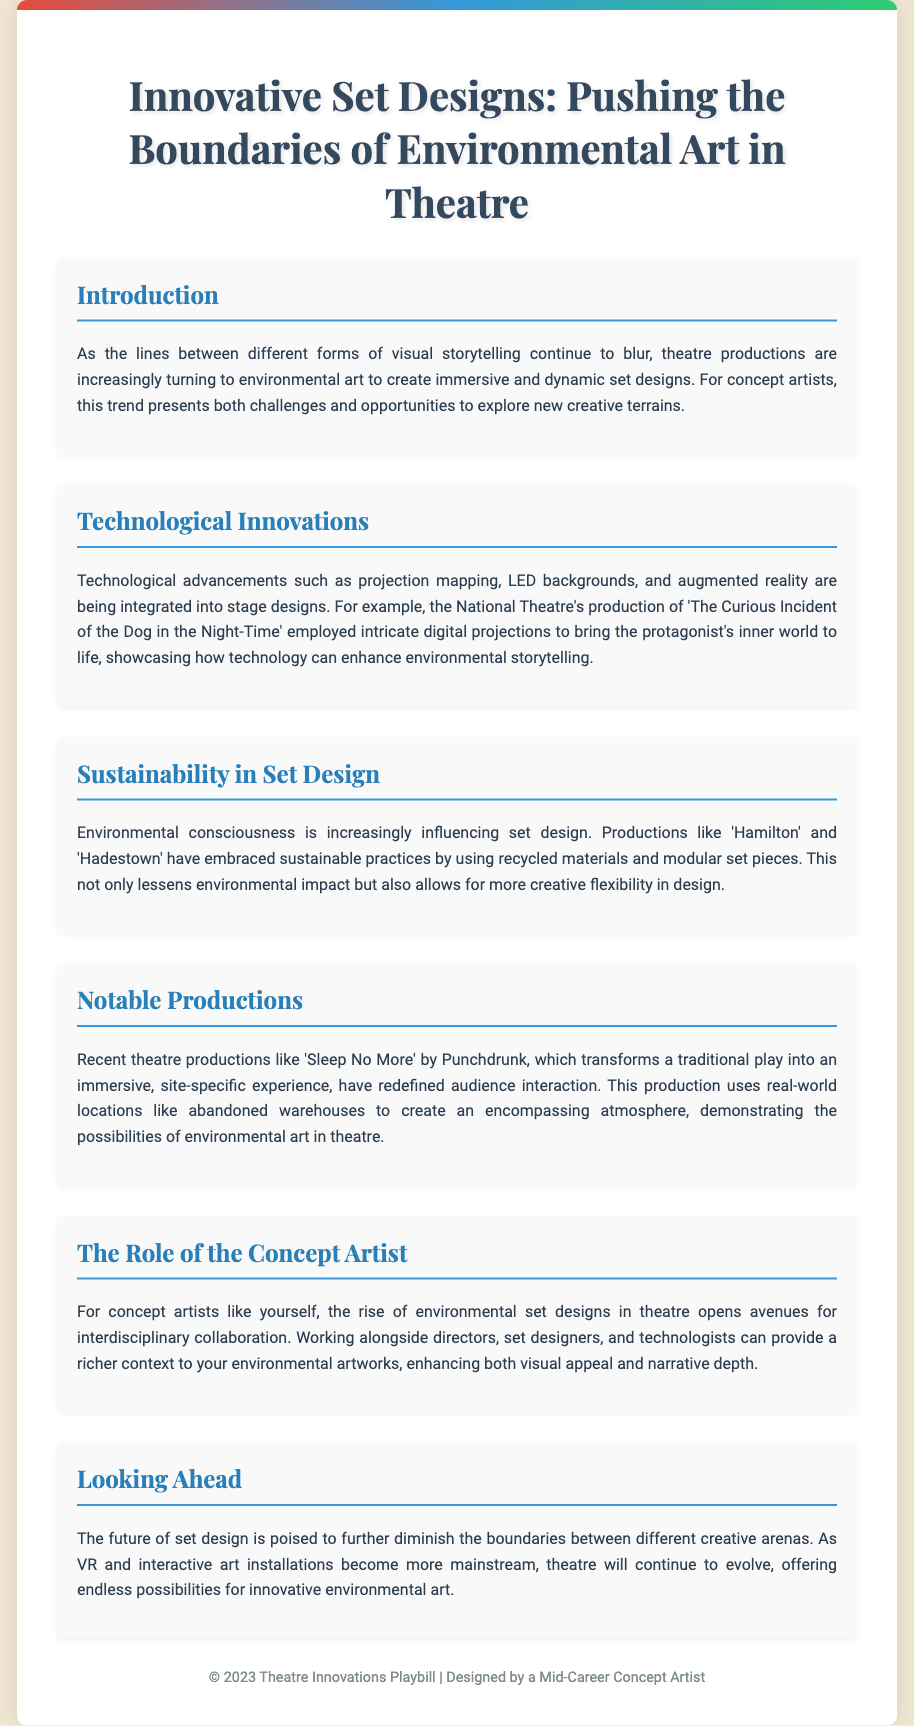what is the title of the Playbill? The title of the Playbill is prominently displayed at the top of the document.
Answer: Innovative Set Designs: Pushing the Boundaries of Environmental Art in Theatre who is the designer of the Playbill? The footer indicates the designer of the Playbill.
Answer: a Mid-Career Concept Artist which production used intricate digital projections? The document specifically mentions a production that utilized digital projections for its set design.
Answer: The Curious Incident of the Dog in the Night-Time what key theme influences contemporary set design according to the document? The document discusses a growing trend in theatre regarding environmental concerns influencing set designs.
Answer: Sustainability what immersive experience does 'Sleep No More' provide? The document describes a specific production that transforms a traditional play into an immersive experience.
Answer: site-specific experience how do recent productions affect audience interaction? The document highlights a certain aspect of theatre productions that has changed in recent years.
Answer: redefined audience interaction which two productions are mentioned for their sustainable practices? The document gives specific example productions that are noted for their sustainable set design approaches.
Answer: Hamilton and Hadestown what future technology is expected to influence set design? The document speculates about the influence of upcoming technologies on the future of set design.
Answer: VR and interactive art installations 